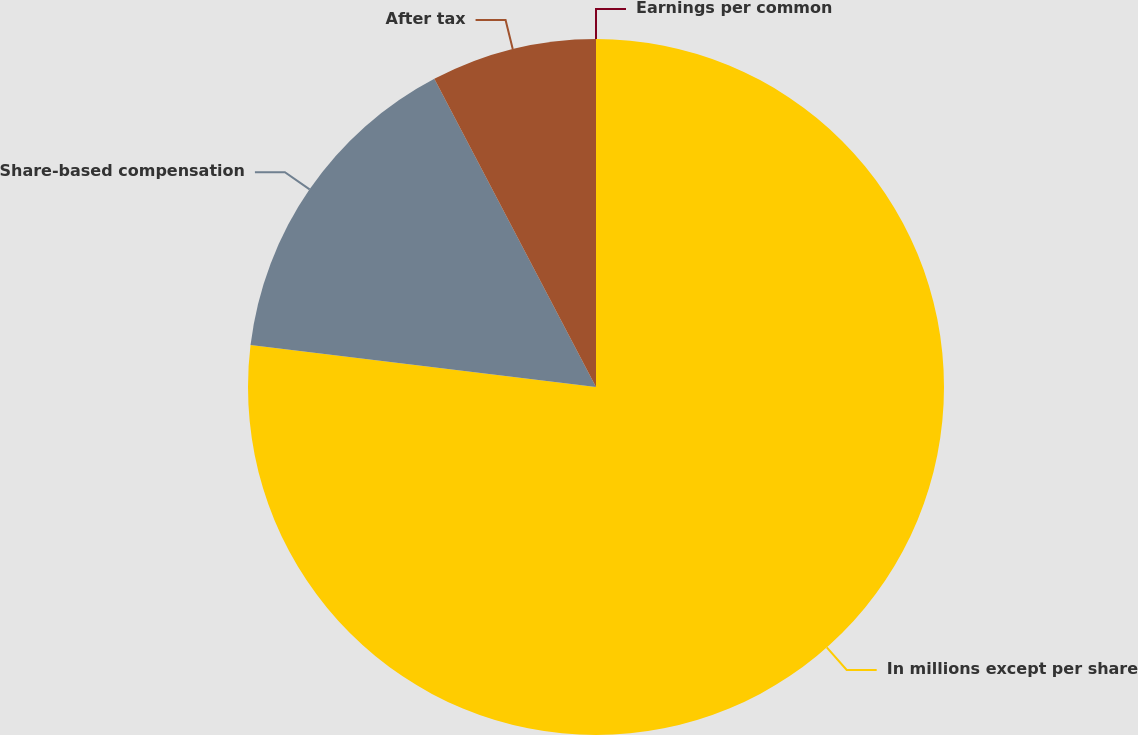Convert chart to OTSL. <chart><loc_0><loc_0><loc_500><loc_500><pie_chart><fcel>In millions except per share<fcel>Share-based compensation<fcel>After tax<fcel>Earnings per common<nl><fcel>76.92%<fcel>15.39%<fcel>7.69%<fcel>0.0%<nl></chart> 